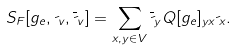<formula> <loc_0><loc_0><loc_500><loc_500>S _ { F } [ g _ { e } , \psi _ { v } , \overline { \psi } _ { v } ] = \sum _ { x , y \in V } \overline { \psi } _ { y } Q [ g _ { e } ] _ { y x } \psi _ { x } .</formula> 